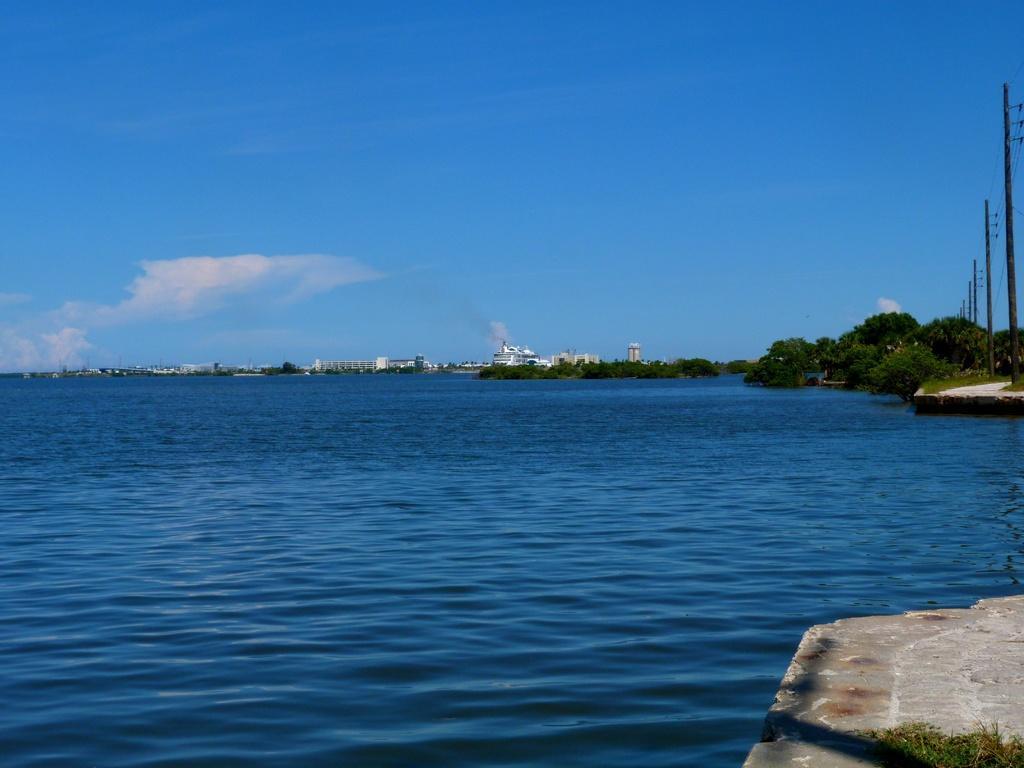How would you summarize this image in a sentence or two? In this image I can see the ground, some grass and the water. In the background I can see few trees, few black colored poles, few buildings and the sky. 